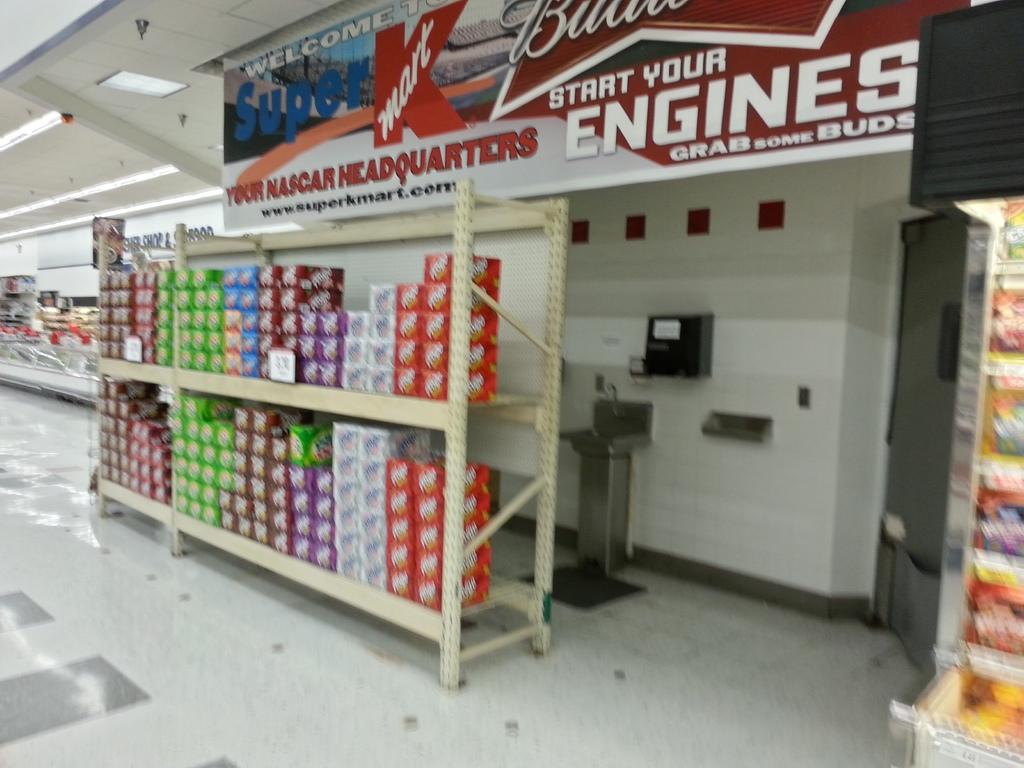<image>
Offer a succinct explanation of the picture presented. a KMART has many cases of soda for sale 